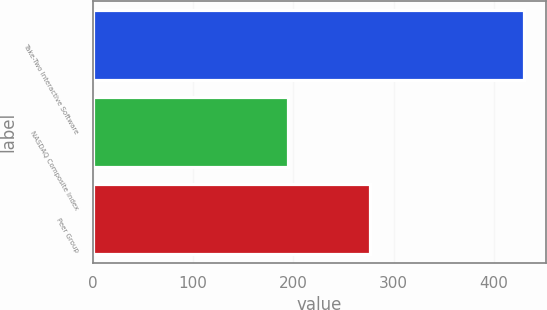<chart> <loc_0><loc_0><loc_500><loc_500><bar_chart><fcel>Take-Two Interactive Software<fcel>NASDAQ Composite Index<fcel>Peer Group<nl><fcel>430.32<fcel>194.97<fcel>276.19<nl></chart> 